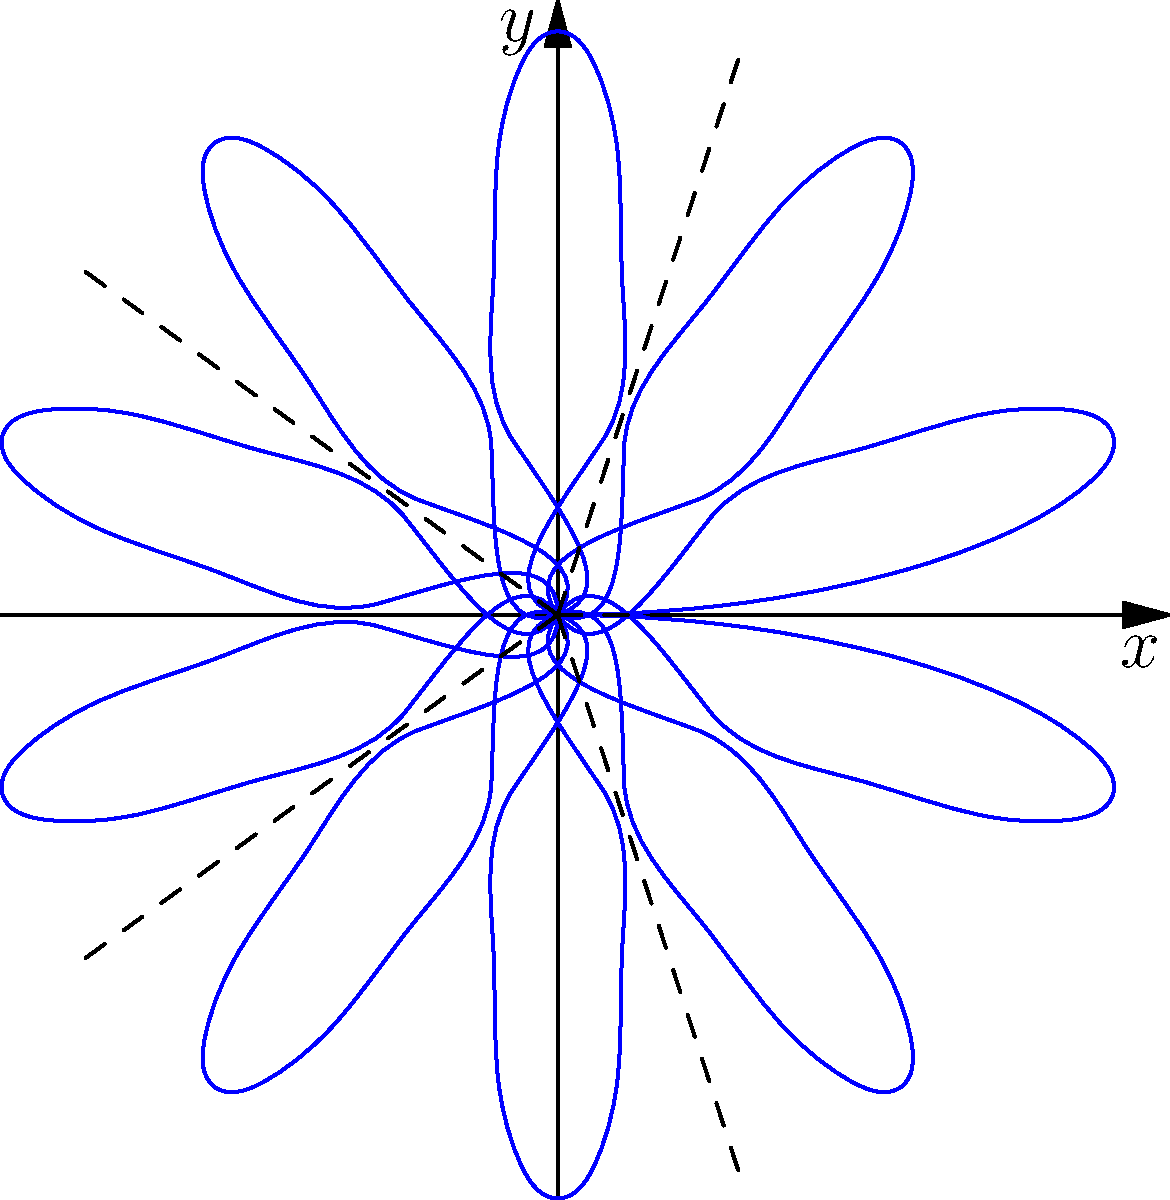In the polar plot of the diffraction pattern through a circular aperture, what is the mathematical expression for the radial distance $r$ as a function of the polar angle $\theta$, given that the pattern exhibits 5-fold symmetry and the intensity reaches zero at regular intervals? To determine the mathematical expression for the radial distance $r$ as a function of the polar angle $\theta$, we need to consider the following steps:

1. Observe the symmetry: The pattern shows 5-fold symmetry, which means it repeats every $\frac{2\pi}{5}$ radians.

2. Identify the oscillation: The intensity (represented by the radial distance) oscillates between 0 and a maximum value.

3. Recognize the sinusoidal nature: The oscillation resembles a sine or cosine function.

4. Determine the frequency: To have 5 lobes in a full $2\pi$ rotation, we need a frequency of 5.

5. Choose the appropriate function: Since the pattern starts at a maximum at $\theta = 0$, we should use the absolute value of a sine function.

6. Formulate the expression: The general form will be $r(\theta) = |\sin(5\theta)|$

This expression satisfies all the observed properties:
- It has 5-fold symmetry due to the factor of 5 in the sine argument.
- It oscillates between 0 and 1, representing the varying intensity.
- It starts at a maximum when $\theta = 0$ and reaches zero at regular intervals.

Therefore, the mathematical expression for the radial distance $r$ as a function of the polar angle $\theta$ is $r(\theta) = |\sin(5\theta)|$.
Answer: $r(\theta) = |\sin(5\theta)|$ 